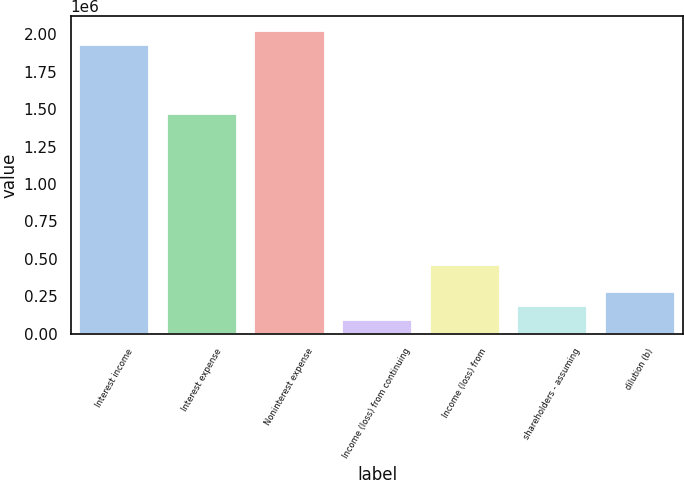<chart> <loc_0><loc_0><loc_500><loc_500><bar_chart><fcel>Interest income<fcel>Interest expense<fcel>Noninterest expense<fcel>Income (loss) from continuing<fcel>Income (loss) from<fcel>shareholders - assuming<fcel>dilution (b)<nl><fcel>1.92912e+06<fcel>1.4698e+06<fcel>2.02098e+06<fcel>91862.9<fcel>459314<fcel>183726<fcel>275588<nl></chart> 